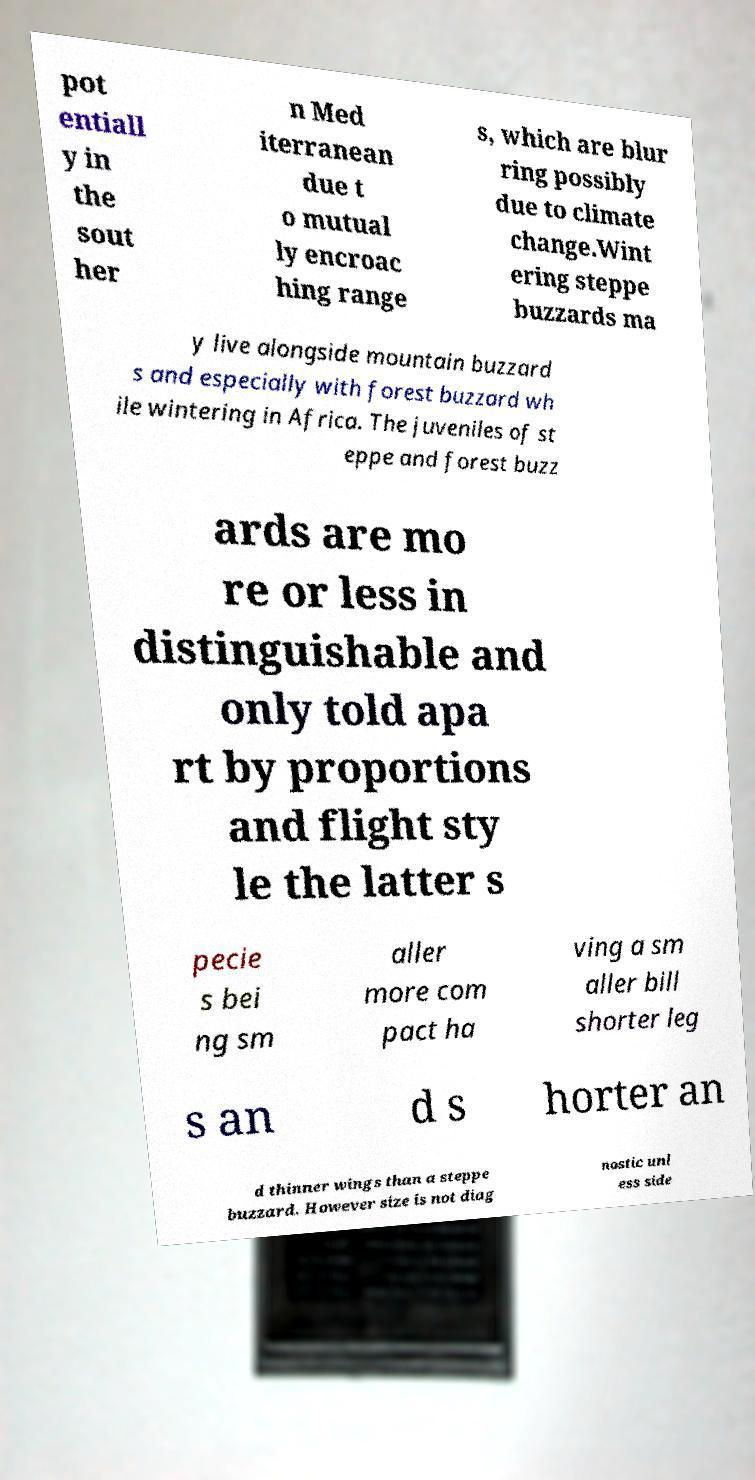There's text embedded in this image that I need extracted. Can you transcribe it verbatim? pot entiall y in the sout her n Med iterranean due t o mutual ly encroac hing range s, which are blur ring possibly due to climate change.Wint ering steppe buzzards ma y live alongside mountain buzzard s and especially with forest buzzard wh ile wintering in Africa. The juveniles of st eppe and forest buzz ards are mo re or less in distinguishable and only told apa rt by proportions and flight sty le the latter s pecie s bei ng sm aller more com pact ha ving a sm aller bill shorter leg s an d s horter an d thinner wings than a steppe buzzard. However size is not diag nostic unl ess side 